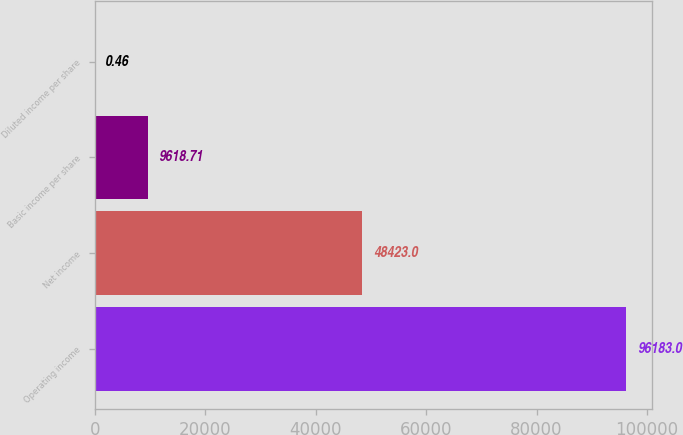Convert chart to OTSL. <chart><loc_0><loc_0><loc_500><loc_500><bar_chart><fcel>Operating income<fcel>Net income<fcel>Basic income per share<fcel>Diluted income per share<nl><fcel>96183<fcel>48423<fcel>9618.71<fcel>0.46<nl></chart> 